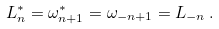Convert formula to latex. <formula><loc_0><loc_0><loc_500><loc_500>L _ { n } ^ { * } = \omega _ { n + 1 } ^ { * } = \omega _ { - n + 1 } = L _ { - n } \, .</formula> 